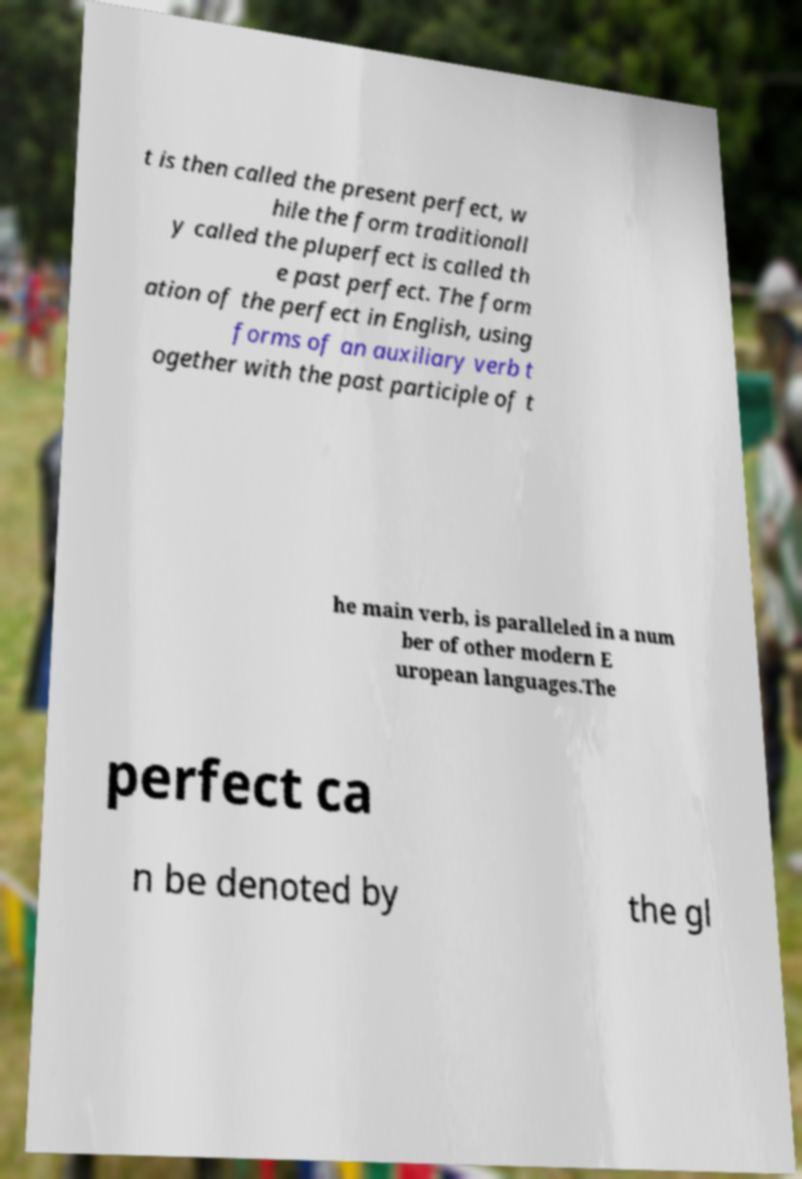Please identify and transcribe the text found in this image. t is then called the present perfect, w hile the form traditionall y called the pluperfect is called th e past perfect. The form ation of the perfect in English, using forms of an auxiliary verb t ogether with the past participle of t he main verb, is paralleled in a num ber of other modern E uropean languages.The perfect ca n be denoted by the gl 